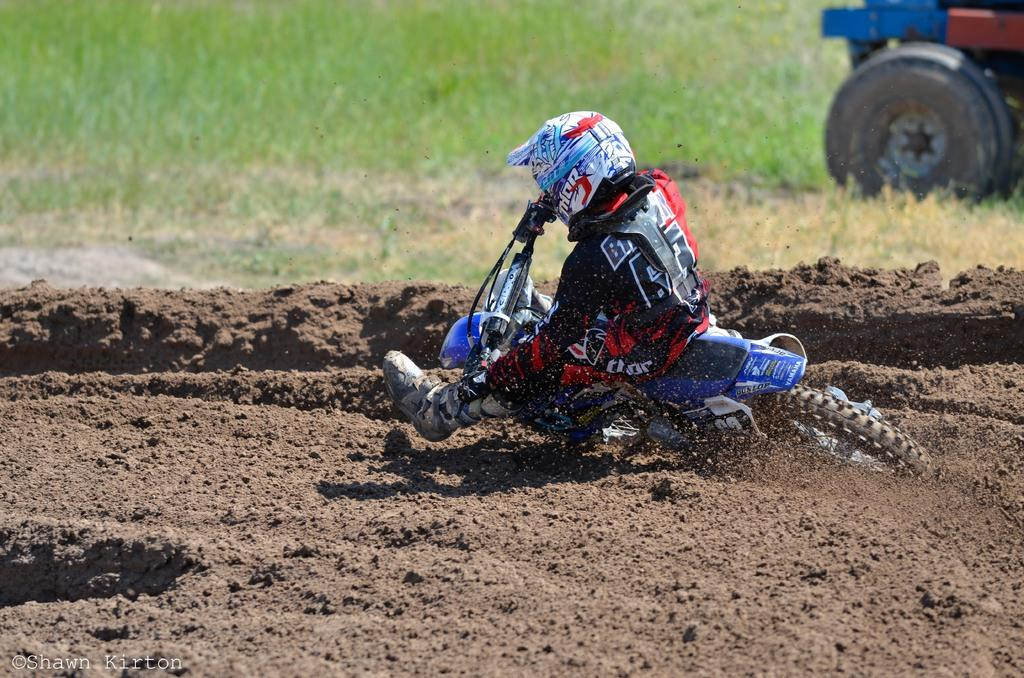What is the person in the image doing? The person is riding a bike in the image. What is the condition of the terrain where the bike is located? The bike is on mud in the image. What is the person wearing while riding the bike? The person is wearing a black and red dress and a helmet. What else can be seen in the image besides the person and the bike? There is a vehicle visible in the image, as well as grass. What type of balloon is the person holding while riding the bike? There is no balloon present in the image; the person is wearing a helmet instead. 